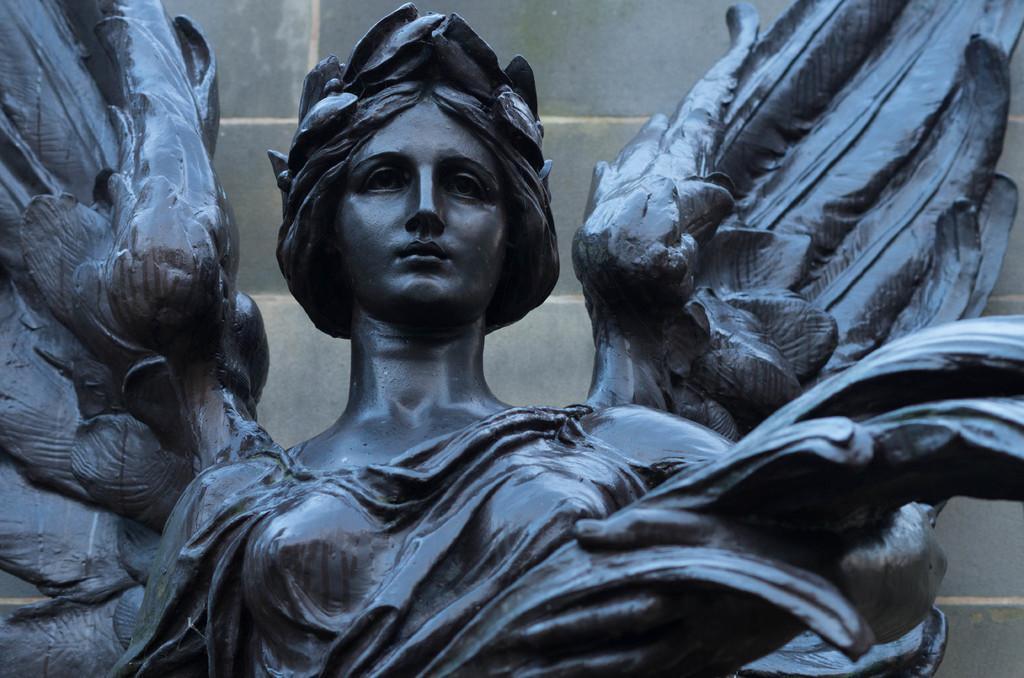How would you summarize this image in a sentence or two? In this picture I can see a statue of a woman. The statue is black in color. In the background I can see a wall. 